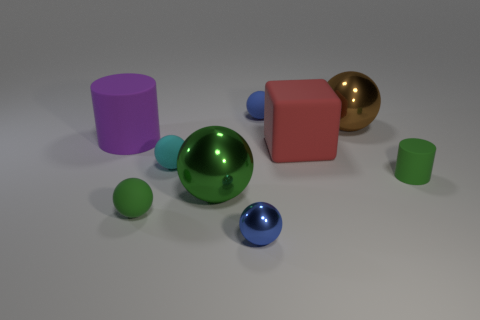Subtract all brown spheres. How many spheres are left? 5 Subtract all tiny cyan spheres. How many spheres are left? 5 Subtract all gray balls. Subtract all red blocks. How many balls are left? 6 Add 1 cyan balls. How many objects exist? 10 Subtract all cylinders. How many objects are left? 7 Add 2 shiny things. How many shiny things are left? 5 Add 8 green rubber spheres. How many green rubber spheres exist? 9 Subtract 1 red blocks. How many objects are left? 8 Subtract all big yellow shiny blocks. Subtract all green rubber cylinders. How many objects are left? 8 